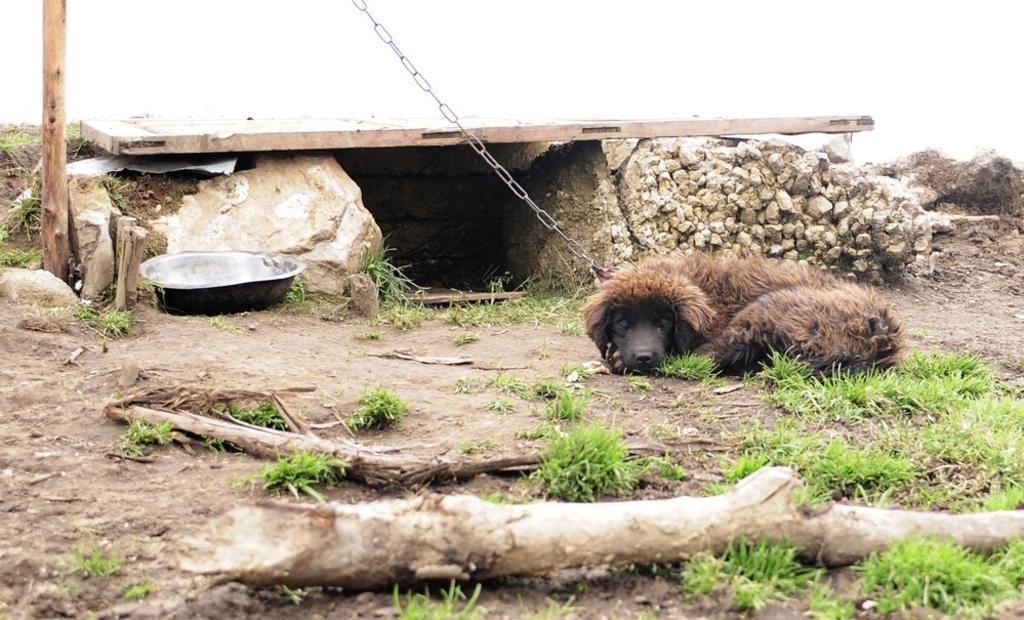Could you give a brief overview of what you see in this image? In this picture we can see some grass and wooden objects on the ground. We can see an animal tied to a chain and this animal is lying on the ground. There is a wooden pole on the left side. We can see a wooden plank on the stones in the background. 